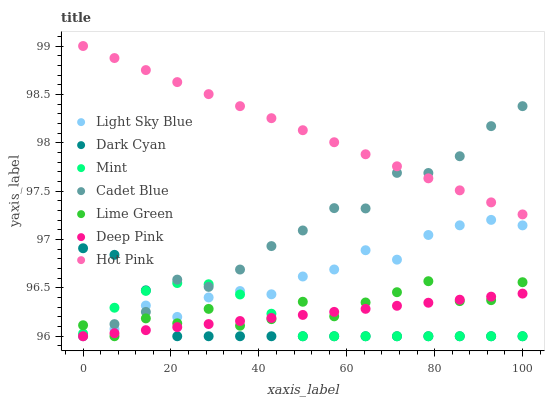Does Dark Cyan have the minimum area under the curve?
Answer yes or no. Yes. Does Hot Pink have the maximum area under the curve?
Answer yes or no. Yes. Does Mint have the minimum area under the curve?
Answer yes or no. No. Does Mint have the maximum area under the curve?
Answer yes or no. No. Is Deep Pink the smoothest?
Answer yes or no. Yes. Is Lime Green the roughest?
Answer yes or no. Yes. Is Mint the smoothest?
Answer yes or no. No. Is Mint the roughest?
Answer yes or no. No. Does Cadet Blue have the lowest value?
Answer yes or no. Yes. Does Hot Pink have the lowest value?
Answer yes or no. No. Does Hot Pink have the highest value?
Answer yes or no. Yes. Does Mint have the highest value?
Answer yes or no. No. Is Dark Cyan less than Hot Pink?
Answer yes or no. Yes. Is Hot Pink greater than Lime Green?
Answer yes or no. Yes. Does Lime Green intersect Cadet Blue?
Answer yes or no. Yes. Is Lime Green less than Cadet Blue?
Answer yes or no. No. Is Lime Green greater than Cadet Blue?
Answer yes or no. No. Does Dark Cyan intersect Hot Pink?
Answer yes or no. No. 